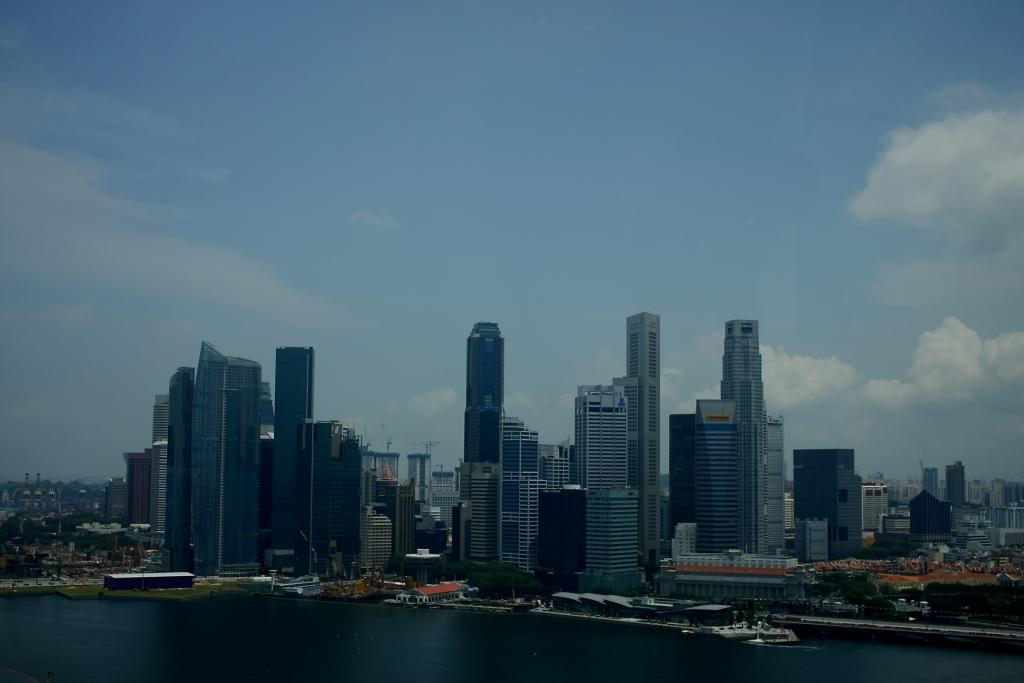Please provide a concise description of this image. In this image I can see the water. To the side of the water there are many sheds. And I can see many buildings in the back. There are also trees to the side of the buildings. In the back I can see the clouds and the blue sky. 